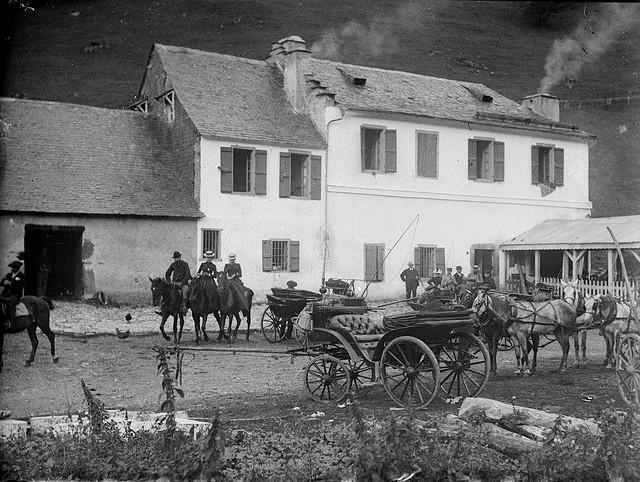How many horses are there?
Give a very brief answer. 2. 